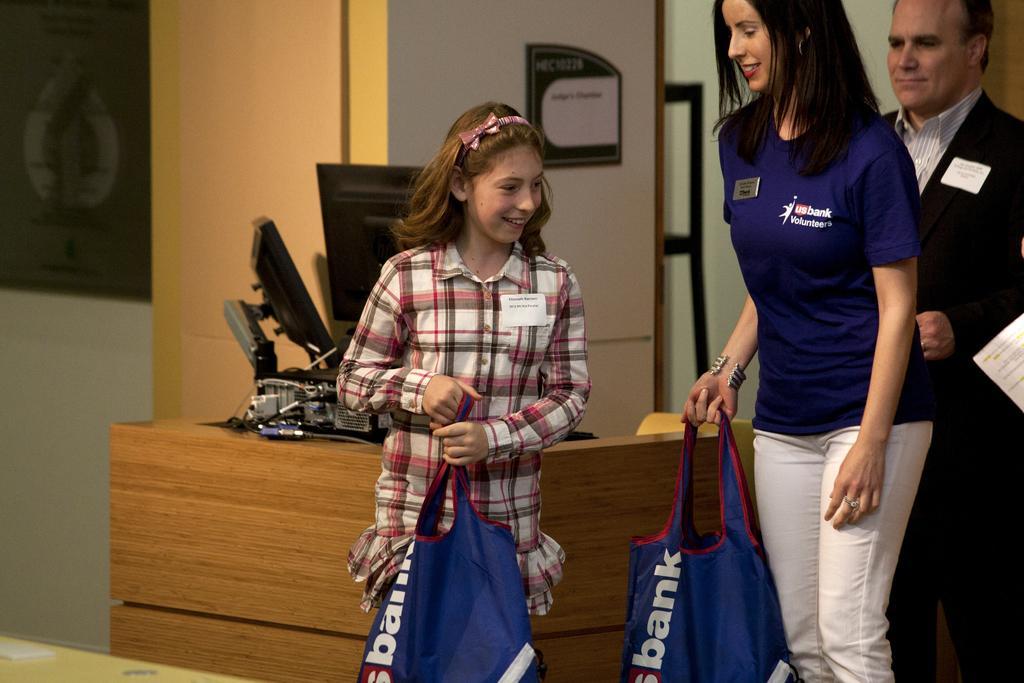In one or two sentences, can you explain what this image depicts? This is the picture where we have three people two women among them are holding some bags and the other guy standing behind them wearing black suit and beside them there is a desk on which we have a system. 